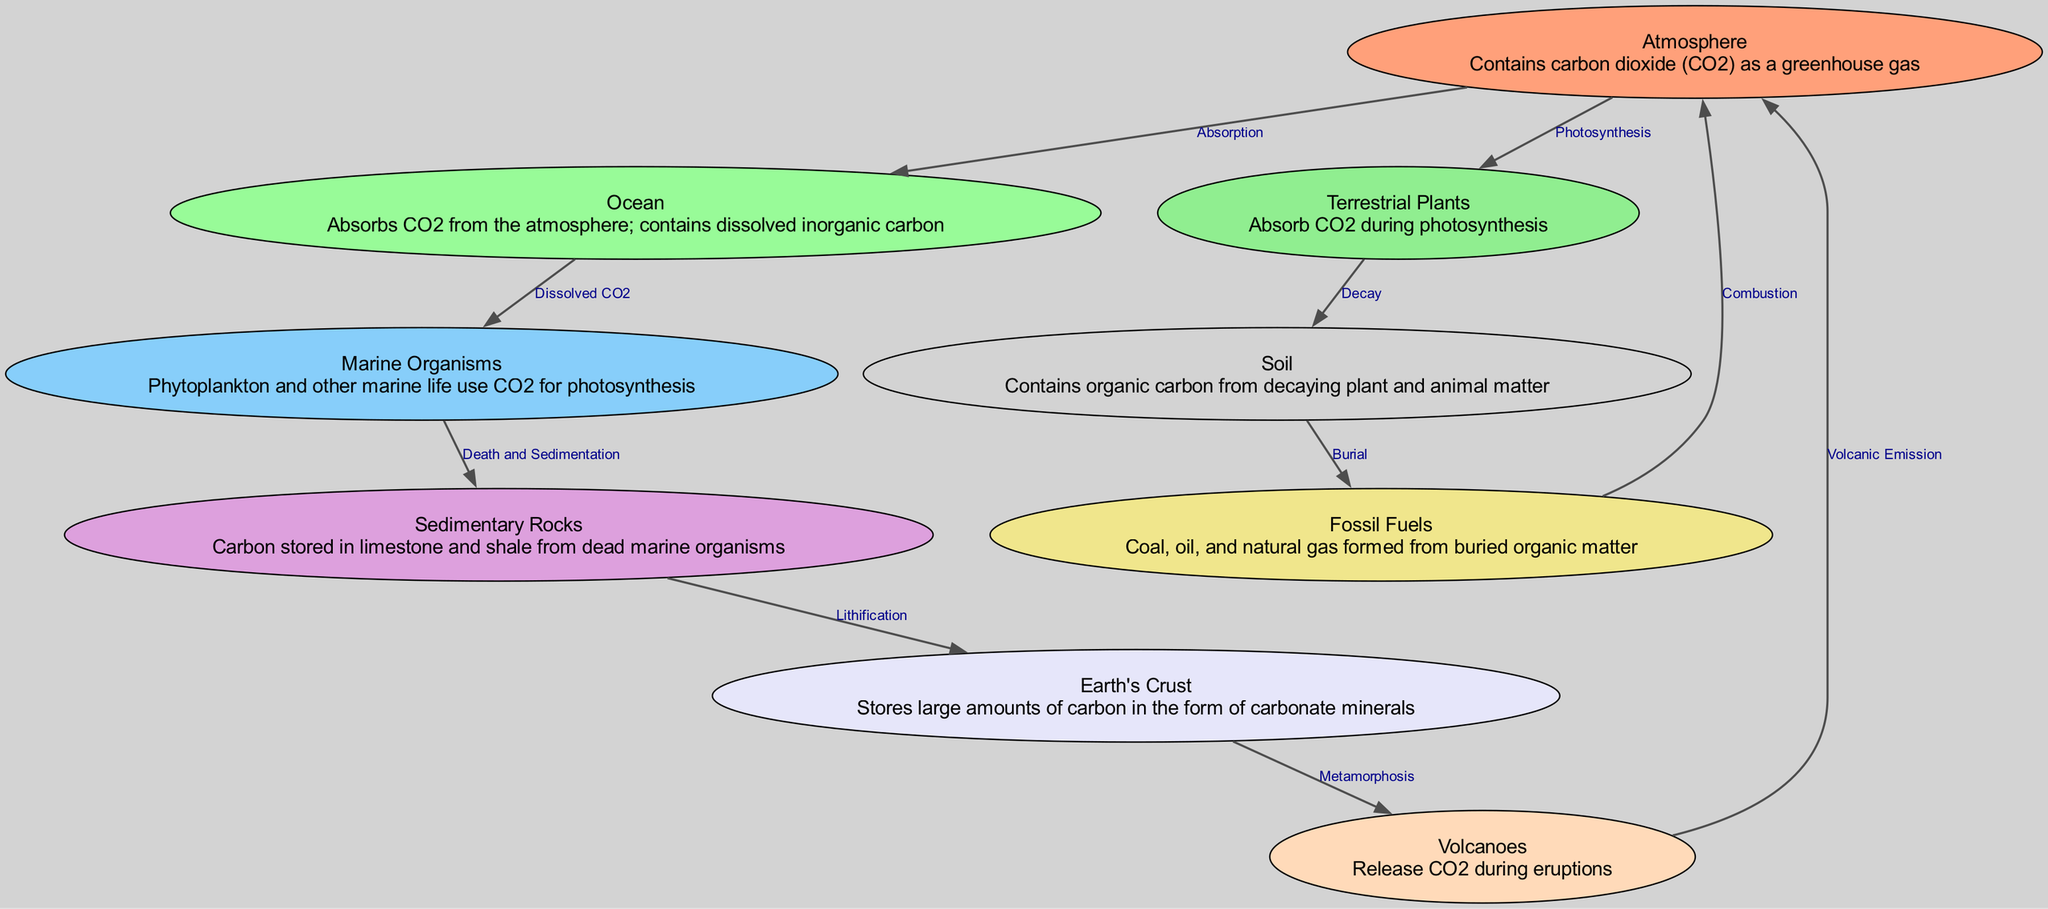What node represents the atmosphere? The diagram lists the node with the label "Atmosphere," which contains carbon dioxide (CO2) as a greenhouse gas. This information is background and can be found in the description associated with that node.
Answer: Atmosphere How many nodes are in the diagram? By counting the nodes shown in the provided data, there are a total of nine distinct nodes representing various components involved in the geological carbon cycle.
Answer: 9 What process connects terrestrial plants to the soil? The diagram shows the connection from "Terrestrial Plants" to "Soil," labeled as "Decay." This indicates that the decay of materials from plants introduces organic carbon into the soil.
Answer: Decay Which nodes are involved in the formation of fossil fuels? To understand the formation of fossil fuels, we look at the nodes connected to "Fossil Fuels." The relevant connections trace back to "Soil" through "Burial." "Soil" provides the organic matter that, through burial processes, eventually forms fossil fuels.
Answer: Soil What emits CO2 back into the atmosphere? Following the diagram, "Volcanoes" are indicated to release CO2 during eruptions back into the atmosphere. Hence, they are a source of CO2 emissions.
Answer: Volcanoes How does CO2 from the atmosphere enter the ocean? The relationship is shown as "Absorption," where it indicates that CO2 diffuses from the atmosphere into the ocean environment, thus transferring carbon dioxide.
Answer: Absorption What is the final destination of carbon in sedimentary rocks? The diagram indicates that carbon stored in sedimentary rocks is a result of a process called "Lithification." This shows the transformation of deposited materials into solid rock.
Answer: Lithification Which node is connected to marine organisms via dissolved CO2? The connection established in the diagram indicates that "Ocean" supplies "Dissolved CO2," which is then utilized by "Marine Organisms," showing a direct relationship.
Answer: Ocean What role do phytoplankton play in the carbon cycle? "Marine Organisms," particularly phytoplankton, use CO2 for photosynthesis, illustrating that they convert carbon into organic matter as an integral part of the carbon cycle.
Answer: Photosynthesis 